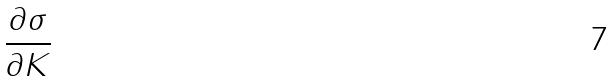Convert formula to latex. <formula><loc_0><loc_0><loc_500><loc_500>\frac { \partial \sigma } { \partial K }</formula> 